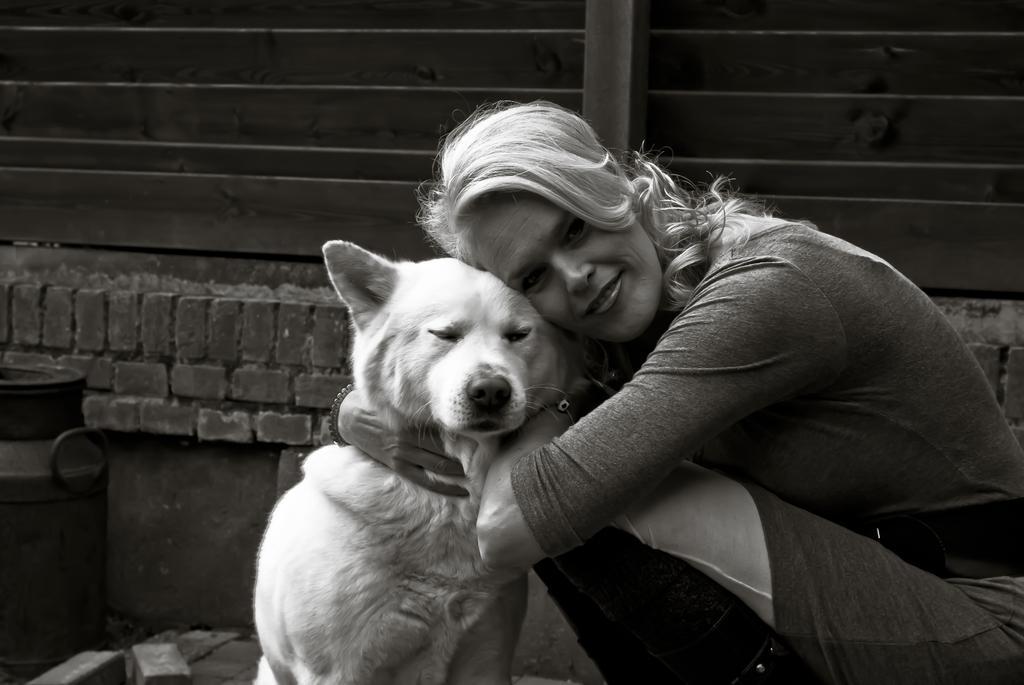How would you summarize this image in a sentence or two? In the image we can see there is a woman who is sitting and holding a dog and she is hugging the dog and the image is in black and white colour. 